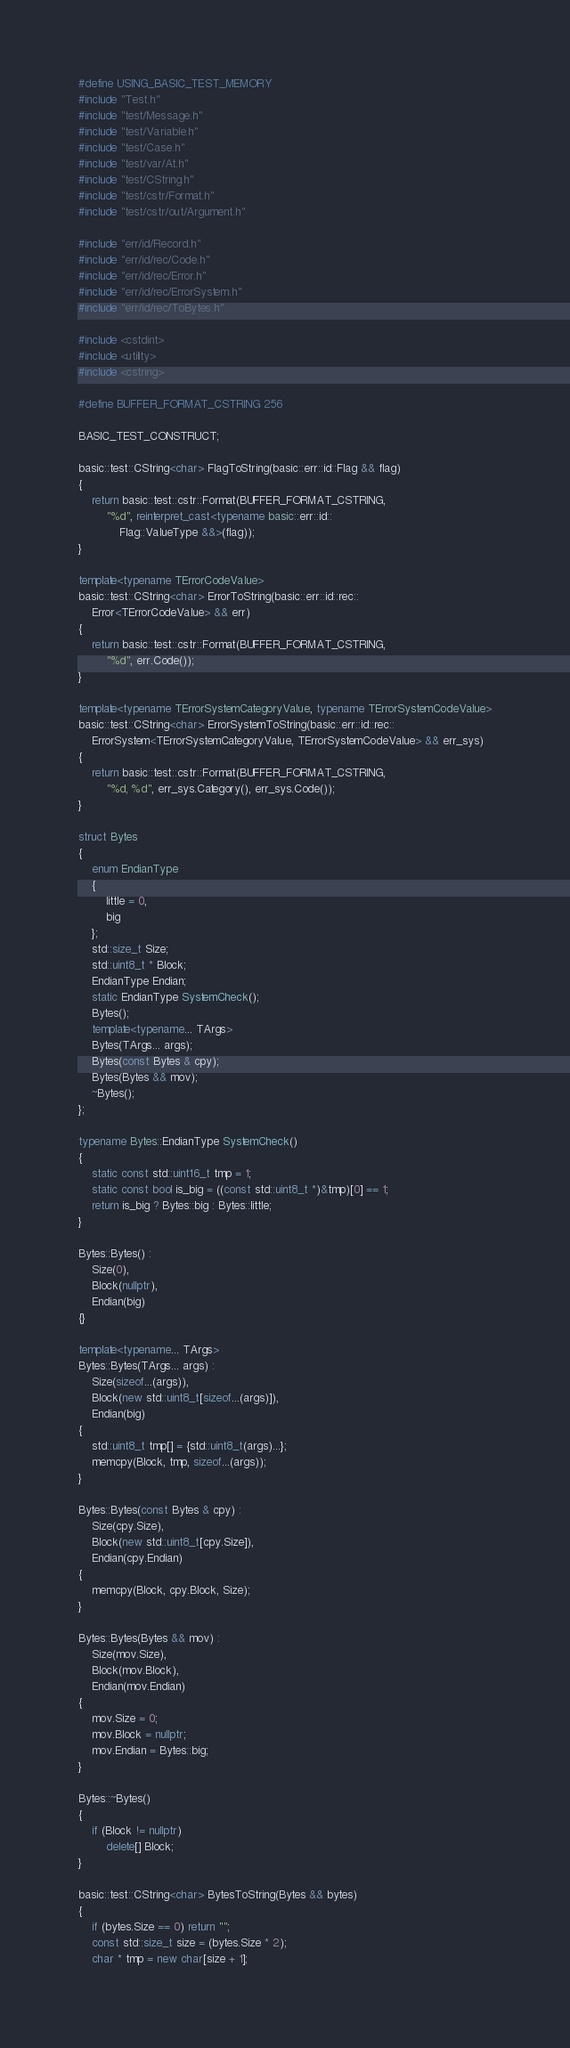Convert code to text. <code><loc_0><loc_0><loc_500><loc_500><_C++_>#define USING_BASIC_TEST_MEMORY
#include "Test.h"
#include "test/Message.h"
#include "test/Variable.h"
#include "test/Case.h"
#include "test/var/At.h"
#include "test/CString.h"
#include "test/cstr/Format.h"
#include "test/cstr/out/Argument.h"

#include "err/id/Record.h"
#include "err/id/rec/Code.h"
#include "err/id/rec/Error.h"
#include "err/id/rec/ErrorSystem.h"
#include "err/id/rec/ToBytes.h"

#include <cstdint>
#include <utility>
#include <cstring>

#define BUFFER_FORMAT_CSTRING 256

BASIC_TEST_CONSTRUCT;

basic::test::CString<char> FlagToString(basic::err::id::Flag && flag)
{
    return basic::test::cstr::Format(BUFFER_FORMAT_CSTRING, 
        "%d", reinterpret_cast<typename basic::err::id::
            Flag::ValueType &&>(flag));
}

template<typename TErrorCodeValue>
basic::test::CString<char> ErrorToString(basic::err::id::rec::
    Error<TErrorCodeValue> && err)
{
    return basic::test::cstr::Format(BUFFER_FORMAT_CSTRING, 
        "%d", err.Code());
}

template<typename TErrorSystemCategoryValue, typename TErrorSystemCodeValue>
basic::test::CString<char> ErrorSystemToString(basic::err::id::rec::
    ErrorSystem<TErrorSystemCategoryValue, TErrorSystemCodeValue> && err_sys)
{
    return basic::test::cstr::Format(BUFFER_FORMAT_CSTRING, 
        "%d, %d", err_sys.Category(), err_sys.Code());
}

struct Bytes
{
    enum EndianType
    {
        little = 0,
        big
    };
    std::size_t Size;
    std::uint8_t * Block;
    EndianType Endian;
    static EndianType SystemCheck();
    Bytes();
    template<typename... TArgs>
    Bytes(TArgs... args);
    Bytes(const Bytes & cpy);
    Bytes(Bytes && mov);
    ~Bytes();
};

typename Bytes::EndianType SystemCheck()
{
    static const std::uint16_t tmp = 1;
    static const bool is_big = ((const std::uint8_t *)&tmp)[0] == 1;
    return is_big ? Bytes::big : Bytes::little;
}

Bytes::Bytes() :
    Size(0),
    Block(nullptr),
    Endian(big)
{}

template<typename... TArgs>
Bytes::Bytes(TArgs... args) :
    Size(sizeof...(args)),
    Block(new std::uint8_t[sizeof...(args)]),
    Endian(big)
{
    std::uint8_t tmp[] = {std::uint8_t(args)...};
    memcpy(Block, tmp, sizeof...(args));
}

Bytes::Bytes(const Bytes & cpy) :
    Size(cpy.Size),
    Block(new std::uint8_t[cpy.Size]),
    Endian(cpy.Endian)
{
    memcpy(Block, cpy.Block, Size);
}

Bytes::Bytes(Bytes && mov) :
    Size(mov.Size),
    Block(mov.Block),
    Endian(mov.Endian)
{
    mov.Size = 0;
    mov.Block = nullptr;
    mov.Endian = Bytes::big;
}

Bytes::~Bytes()
{
    if (Block != nullptr)
        delete[] Block;
}

basic::test::CString<char> BytesToString(Bytes && bytes)
{
    if (bytes.Size == 0) return "";
    const std::size_t size = (bytes.Size * 2);
    char * tmp = new char[size + 1];</code> 